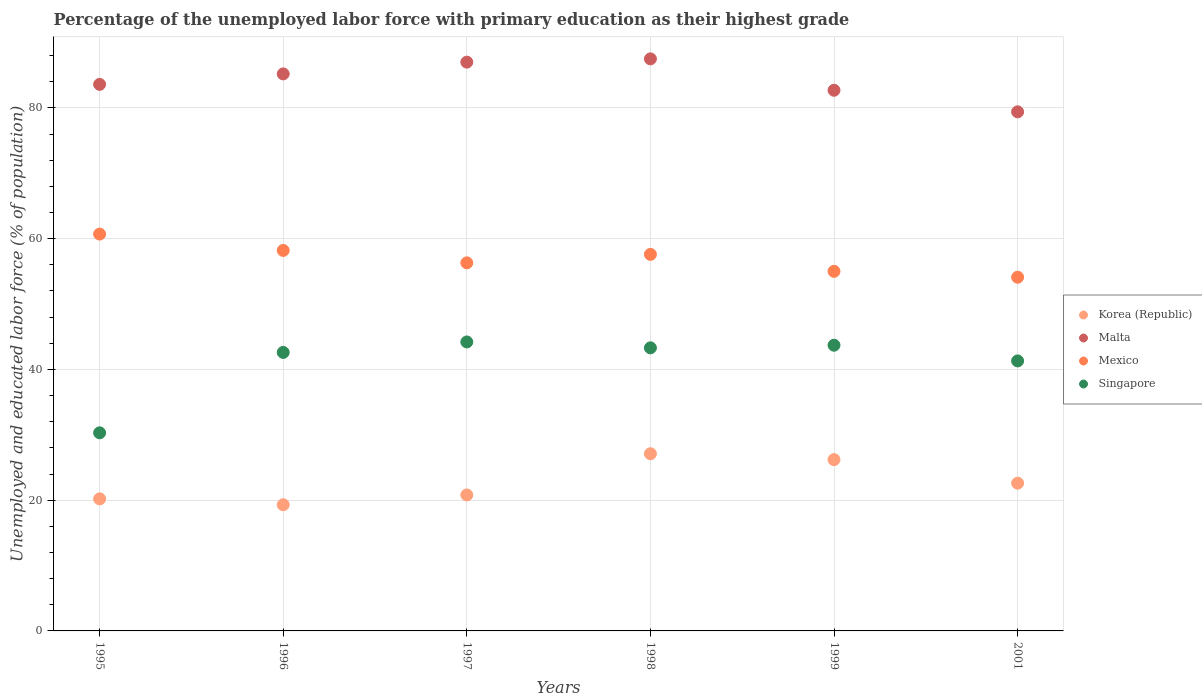How many different coloured dotlines are there?
Make the answer very short. 4. What is the percentage of the unemployed labor force with primary education in Korea (Republic) in 1996?
Keep it short and to the point. 19.3. Across all years, what is the maximum percentage of the unemployed labor force with primary education in Mexico?
Provide a short and direct response. 60.7. Across all years, what is the minimum percentage of the unemployed labor force with primary education in Mexico?
Your response must be concise. 54.1. In which year was the percentage of the unemployed labor force with primary education in Korea (Republic) maximum?
Keep it short and to the point. 1998. What is the total percentage of the unemployed labor force with primary education in Mexico in the graph?
Provide a short and direct response. 341.9. What is the difference between the percentage of the unemployed labor force with primary education in Malta in 1996 and that in 1998?
Provide a short and direct response. -2.3. What is the difference between the percentage of the unemployed labor force with primary education in Singapore in 1998 and the percentage of the unemployed labor force with primary education in Mexico in 1995?
Your answer should be very brief. -17.4. What is the average percentage of the unemployed labor force with primary education in Singapore per year?
Offer a very short reply. 40.9. In the year 1999, what is the difference between the percentage of the unemployed labor force with primary education in Singapore and percentage of the unemployed labor force with primary education in Korea (Republic)?
Give a very brief answer. 17.5. What is the ratio of the percentage of the unemployed labor force with primary education in Korea (Republic) in 1998 to that in 2001?
Keep it short and to the point. 1.2. What is the difference between the highest and the second highest percentage of the unemployed labor force with primary education in Korea (Republic)?
Your answer should be compact. 0.9. What is the difference between the highest and the lowest percentage of the unemployed labor force with primary education in Mexico?
Keep it short and to the point. 6.6. In how many years, is the percentage of the unemployed labor force with primary education in Korea (Republic) greater than the average percentage of the unemployed labor force with primary education in Korea (Republic) taken over all years?
Give a very brief answer. 2. Is it the case that in every year, the sum of the percentage of the unemployed labor force with primary education in Singapore and percentage of the unemployed labor force with primary education in Mexico  is greater than the sum of percentage of the unemployed labor force with primary education in Malta and percentage of the unemployed labor force with primary education in Korea (Republic)?
Provide a succinct answer. Yes. Does the percentage of the unemployed labor force with primary education in Korea (Republic) monotonically increase over the years?
Provide a short and direct response. No. Is the percentage of the unemployed labor force with primary education in Malta strictly greater than the percentage of the unemployed labor force with primary education in Singapore over the years?
Provide a short and direct response. Yes. Is the percentage of the unemployed labor force with primary education in Korea (Republic) strictly less than the percentage of the unemployed labor force with primary education in Singapore over the years?
Provide a succinct answer. Yes. How many dotlines are there?
Provide a succinct answer. 4. How many years are there in the graph?
Make the answer very short. 6. Where does the legend appear in the graph?
Keep it short and to the point. Center right. How are the legend labels stacked?
Give a very brief answer. Vertical. What is the title of the graph?
Offer a terse response. Percentage of the unemployed labor force with primary education as their highest grade. Does "Sub-Saharan Africa (developing only)" appear as one of the legend labels in the graph?
Offer a very short reply. No. What is the label or title of the X-axis?
Give a very brief answer. Years. What is the label or title of the Y-axis?
Ensure brevity in your answer.  Unemployed and educated labor force (% of population). What is the Unemployed and educated labor force (% of population) in Korea (Republic) in 1995?
Your answer should be very brief. 20.2. What is the Unemployed and educated labor force (% of population) in Malta in 1995?
Your answer should be very brief. 83.6. What is the Unemployed and educated labor force (% of population) of Mexico in 1995?
Offer a very short reply. 60.7. What is the Unemployed and educated labor force (% of population) in Singapore in 1995?
Ensure brevity in your answer.  30.3. What is the Unemployed and educated labor force (% of population) of Korea (Republic) in 1996?
Make the answer very short. 19.3. What is the Unemployed and educated labor force (% of population) in Malta in 1996?
Give a very brief answer. 85.2. What is the Unemployed and educated labor force (% of population) of Mexico in 1996?
Your answer should be very brief. 58.2. What is the Unemployed and educated labor force (% of population) in Singapore in 1996?
Your answer should be compact. 42.6. What is the Unemployed and educated labor force (% of population) in Korea (Republic) in 1997?
Offer a very short reply. 20.8. What is the Unemployed and educated labor force (% of population) in Malta in 1997?
Ensure brevity in your answer.  87. What is the Unemployed and educated labor force (% of population) of Mexico in 1997?
Your answer should be compact. 56.3. What is the Unemployed and educated labor force (% of population) of Singapore in 1997?
Keep it short and to the point. 44.2. What is the Unemployed and educated labor force (% of population) of Korea (Republic) in 1998?
Your answer should be compact. 27.1. What is the Unemployed and educated labor force (% of population) of Malta in 1998?
Offer a terse response. 87.5. What is the Unemployed and educated labor force (% of population) in Mexico in 1998?
Ensure brevity in your answer.  57.6. What is the Unemployed and educated labor force (% of population) in Singapore in 1998?
Give a very brief answer. 43.3. What is the Unemployed and educated labor force (% of population) of Korea (Republic) in 1999?
Offer a terse response. 26.2. What is the Unemployed and educated labor force (% of population) of Malta in 1999?
Provide a succinct answer. 82.7. What is the Unemployed and educated labor force (% of population) in Singapore in 1999?
Make the answer very short. 43.7. What is the Unemployed and educated labor force (% of population) in Korea (Republic) in 2001?
Offer a very short reply. 22.6. What is the Unemployed and educated labor force (% of population) of Malta in 2001?
Provide a succinct answer. 79.4. What is the Unemployed and educated labor force (% of population) of Mexico in 2001?
Your answer should be very brief. 54.1. What is the Unemployed and educated labor force (% of population) of Singapore in 2001?
Make the answer very short. 41.3. Across all years, what is the maximum Unemployed and educated labor force (% of population) in Korea (Republic)?
Your answer should be compact. 27.1. Across all years, what is the maximum Unemployed and educated labor force (% of population) of Malta?
Keep it short and to the point. 87.5. Across all years, what is the maximum Unemployed and educated labor force (% of population) in Mexico?
Offer a very short reply. 60.7. Across all years, what is the maximum Unemployed and educated labor force (% of population) in Singapore?
Give a very brief answer. 44.2. Across all years, what is the minimum Unemployed and educated labor force (% of population) in Korea (Republic)?
Offer a terse response. 19.3. Across all years, what is the minimum Unemployed and educated labor force (% of population) of Malta?
Provide a short and direct response. 79.4. Across all years, what is the minimum Unemployed and educated labor force (% of population) of Mexico?
Keep it short and to the point. 54.1. Across all years, what is the minimum Unemployed and educated labor force (% of population) in Singapore?
Offer a very short reply. 30.3. What is the total Unemployed and educated labor force (% of population) in Korea (Republic) in the graph?
Provide a succinct answer. 136.2. What is the total Unemployed and educated labor force (% of population) of Malta in the graph?
Make the answer very short. 505.4. What is the total Unemployed and educated labor force (% of population) in Mexico in the graph?
Make the answer very short. 341.9. What is the total Unemployed and educated labor force (% of population) of Singapore in the graph?
Your answer should be very brief. 245.4. What is the difference between the Unemployed and educated labor force (% of population) in Korea (Republic) in 1995 and that in 1997?
Ensure brevity in your answer.  -0.6. What is the difference between the Unemployed and educated labor force (% of population) of Malta in 1995 and that in 1997?
Ensure brevity in your answer.  -3.4. What is the difference between the Unemployed and educated labor force (% of population) in Singapore in 1995 and that in 1997?
Provide a succinct answer. -13.9. What is the difference between the Unemployed and educated labor force (% of population) of Korea (Republic) in 1995 and that in 1998?
Give a very brief answer. -6.9. What is the difference between the Unemployed and educated labor force (% of population) in Malta in 1995 and that in 1998?
Offer a very short reply. -3.9. What is the difference between the Unemployed and educated labor force (% of population) of Mexico in 1995 and that in 1998?
Keep it short and to the point. 3.1. What is the difference between the Unemployed and educated labor force (% of population) in Korea (Republic) in 1995 and that in 1999?
Ensure brevity in your answer.  -6. What is the difference between the Unemployed and educated labor force (% of population) of Mexico in 1995 and that in 1999?
Your answer should be compact. 5.7. What is the difference between the Unemployed and educated labor force (% of population) of Singapore in 1995 and that in 1999?
Give a very brief answer. -13.4. What is the difference between the Unemployed and educated labor force (% of population) in Korea (Republic) in 1995 and that in 2001?
Keep it short and to the point. -2.4. What is the difference between the Unemployed and educated labor force (% of population) of Malta in 1995 and that in 2001?
Offer a terse response. 4.2. What is the difference between the Unemployed and educated labor force (% of population) in Mexico in 1995 and that in 2001?
Your answer should be compact. 6.6. What is the difference between the Unemployed and educated labor force (% of population) in Singapore in 1995 and that in 2001?
Your answer should be compact. -11. What is the difference between the Unemployed and educated labor force (% of population) in Mexico in 1996 and that in 1997?
Offer a very short reply. 1.9. What is the difference between the Unemployed and educated labor force (% of population) in Singapore in 1996 and that in 1997?
Your answer should be compact. -1.6. What is the difference between the Unemployed and educated labor force (% of population) in Korea (Republic) in 1996 and that in 1998?
Give a very brief answer. -7.8. What is the difference between the Unemployed and educated labor force (% of population) of Mexico in 1996 and that in 1998?
Offer a terse response. 0.6. What is the difference between the Unemployed and educated labor force (% of population) in Korea (Republic) in 1996 and that in 1999?
Provide a short and direct response. -6.9. What is the difference between the Unemployed and educated labor force (% of population) of Malta in 1996 and that in 1999?
Give a very brief answer. 2.5. What is the difference between the Unemployed and educated labor force (% of population) in Mexico in 1996 and that in 1999?
Provide a short and direct response. 3.2. What is the difference between the Unemployed and educated labor force (% of population) of Singapore in 1996 and that in 1999?
Ensure brevity in your answer.  -1.1. What is the difference between the Unemployed and educated labor force (% of population) in Korea (Republic) in 1996 and that in 2001?
Make the answer very short. -3.3. What is the difference between the Unemployed and educated labor force (% of population) in Mexico in 1996 and that in 2001?
Offer a very short reply. 4.1. What is the difference between the Unemployed and educated labor force (% of population) of Korea (Republic) in 1997 and that in 1998?
Provide a short and direct response. -6.3. What is the difference between the Unemployed and educated labor force (% of population) in Malta in 1997 and that in 1998?
Make the answer very short. -0.5. What is the difference between the Unemployed and educated labor force (% of population) of Malta in 1997 and that in 1999?
Your answer should be very brief. 4.3. What is the difference between the Unemployed and educated labor force (% of population) of Singapore in 1997 and that in 1999?
Give a very brief answer. 0.5. What is the difference between the Unemployed and educated labor force (% of population) of Korea (Republic) in 1997 and that in 2001?
Your answer should be compact. -1.8. What is the difference between the Unemployed and educated labor force (% of population) of Malta in 1997 and that in 2001?
Provide a short and direct response. 7.6. What is the difference between the Unemployed and educated labor force (% of population) in Singapore in 1997 and that in 2001?
Offer a terse response. 2.9. What is the difference between the Unemployed and educated labor force (% of population) in Malta in 1998 and that in 1999?
Give a very brief answer. 4.8. What is the difference between the Unemployed and educated labor force (% of population) of Mexico in 1998 and that in 1999?
Your answer should be very brief. 2.6. What is the difference between the Unemployed and educated labor force (% of population) of Korea (Republic) in 1998 and that in 2001?
Ensure brevity in your answer.  4.5. What is the difference between the Unemployed and educated labor force (% of population) in Malta in 1998 and that in 2001?
Your answer should be very brief. 8.1. What is the difference between the Unemployed and educated labor force (% of population) in Singapore in 1998 and that in 2001?
Give a very brief answer. 2. What is the difference between the Unemployed and educated labor force (% of population) in Malta in 1999 and that in 2001?
Ensure brevity in your answer.  3.3. What is the difference between the Unemployed and educated labor force (% of population) of Mexico in 1999 and that in 2001?
Your answer should be very brief. 0.9. What is the difference between the Unemployed and educated labor force (% of population) of Singapore in 1999 and that in 2001?
Provide a succinct answer. 2.4. What is the difference between the Unemployed and educated labor force (% of population) of Korea (Republic) in 1995 and the Unemployed and educated labor force (% of population) of Malta in 1996?
Make the answer very short. -65. What is the difference between the Unemployed and educated labor force (% of population) of Korea (Republic) in 1995 and the Unemployed and educated labor force (% of population) of Mexico in 1996?
Provide a succinct answer. -38. What is the difference between the Unemployed and educated labor force (% of population) in Korea (Republic) in 1995 and the Unemployed and educated labor force (% of population) in Singapore in 1996?
Offer a very short reply. -22.4. What is the difference between the Unemployed and educated labor force (% of population) in Malta in 1995 and the Unemployed and educated labor force (% of population) in Mexico in 1996?
Offer a terse response. 25.4. What is the difference between the Unemployed and educated labor force (% of population) of Malta in 1995 and the Unemployed and educated labor force (% of population) of Singapore in 1996?
Make the answer very short. 41. What is the difference between the Unemployed and educated labor force (% of population) in Mexico in 1995 and the Unemployed and educated labor force (% of population) in Singapore in 1996?
Your response must be concise. 18.1. What is the difference between the Unemployed and educated labor force (% of population) of Korea (Republic) in 1995 and the Unemployed and educated labor force (% of population) of Malta in 1997?
Give a very brief answer. -66.8. What is the difference between the Unemployed and educated labor force (% of population) in Korea (Republic) in 1995 and the Unemployed and educated labor force (% of population) in Mexico in 1997?
Ensure brevity in your answer.  -36.1. What is the difference between the Unemployed and educated labor force (% of population) in Malta in 1995 and the Unemployed and educated labor force (% of population) in Mexico in 1997?
Offer a very short reply. 27.3. What is the difference between the Unemployed and educated labor force (% of population) of Malta in 1995 and the Unemployed and educated labor force (% of population) of Singapore in 1997?
Ensure brevity in your answer.  39.4. What is the difference between the Unemployed and educated labor force (% of population) in Korea (Republic) in 1995 and the Unemployed and educated labor force (% of population) in Malta in 1998?
Make the answer very short. -67.3. What is the difference between the Unemployed and educated labor force (% of population) of Korea (Republic) in 1995 and the Unemployed and educated labor force (% of population) of Mexico in 1998?
Provide a succinct answer. -37.4. What is the difference between the Unemployed and educated labor force (% of population) of Korea (Republic) in 1995 and the Unemployed and educated labor force (% of population) of Singapore in 1998?
Offer a terse response. -23.1. What is the difference between the Unemployed and educated labor force (% of population) of Malta in 1995 and the Unemployed and educated labor force (% of population) of Singapore in 1998?
Your answer should be very brief. 40.3. What is the difference between the Unemployed and educated labor force (% of population) in Mexico in 1995 and the Unemployed and educated labor force (% of population) in Singapore in 1998?
Your response must be concise. 17.4. What is the difference between the Unemployed and educated labor force (% of population) of Korea (Republic) in 1995 and the Unemployed and educated labor force (% of population) of Malta in 1999?
Provide a succinct answer. -62.5. What is the difference between the Unemployed and educated labor force (% of population) of Korea (Republic) in 1995 and the Unemployed and educated labor force (% of population) of Mexico in 1999?
Offer a terse response. -34.8. What is the difference between the Unemployed and educated labor force (% of population) in Korea (Republic) in 1995 and the Unemployed and educated labor force (% of population) in Singapore in 1999?
Your response must be concise. -23.5. What is the difference between the Unemployed and educated labor force (% of population) of Malta in 1995 and the Unemployed and educated labor force (% of population) of Mexico in 1999?
Make the answer very short. 28.6. What is the difference between the Unemployed and educated labor force (% of population) of Malta in 1995 and the Unemployed and educated labor force (% of population) of Singapore in 1999?
Your answer should be very brief. 39.9. What is the difference between the Unemployed and educated labor force (% of population) of Mexico in 1995 and the Unemployed and educated labor force (% of population) of Singapore in 1999?
Provide a short and direct response. 17. What is the difference between the Unemployed and educated labor force (% of population) in Korea (Republic) in 1995 and the Unemployed and educated labor force (% of population) in Malta in 2001?
Your answer should be very brief. -59.2. What is the difference between the Unemployed and educated labor force (% of population) of Korea (Republic) in 1995 and the Unemployed and educated labor force (% of population) of Mexico in 2001?
Provide a succinct answer. -33.9. What is the difference between the Unemployed and educated labor force (% of population) in Korea (Republic) in 1995 and the Unemployed and educated labor force (% of population) in Singapore in 2001?
Keep it short and to the point. -21.1. What is the difference between the Unemployed and educated labor force (% of population) of Malta in 1995 and the Unemployed and educated labor force (% of population) of Mexico in 2001?
Provide a succinct answer. 29.5. What is the difference between the Unemployed and educated labor force (% of population) of Malta in 1995 and the Unemployed and educated labor force (% of population) of Singapore in 2001?
Offer a terse response. 42.3. What is the difference between the Unemployed and educated labor force (% of population) in Mexico in 1995 and the Unemployed and educated labor force (% of population) in Singapore in 2001?
Give a very brief answer. 19.4. What is the difference between the Unemployed and educated labor force (% of population) in Korea (Republic) in 1996 and the Unemployed and educated labor force (% of population) in Malta in 1997?
Ensure brevity in your answer.  -67.7. What is the difference between the Unemployed and educated labor force (% of population) of Korea (Republic) in 1996 and the Unemployed and educated labor force (% of population) of Mexico in 1997?
Make the answer very short. -37. What is the difference between the Unemployed and educated labor force (% of population) in Korea (Republic) in 1996 and the Unemployed and educated labor force (% of population) in Singapore in 1997?
Your answer should be very brief. -24.9. What is the difference between the Unemployed and educated labor force (% of population) of Malta in 1996 and the Unemployed and educated labor force (% of population) of Mexico in 1997?
Ensure brevity in your answer.  28.9. What is the difference between the Unemployed and educated labor force (% of population) in Malta in 1996 and the Unemployed and educated labor force (% of population) in Singapore in 1997?
Provide a short and direct response. 41. What is the difference between the Unemployed and educated labor force (% of population) in Mexico in 1996 and the Unemployed and educated labor force (% of population) in Singapore in 1997?
Provide a short and direct response. 14. What is the difference between the Unemployed and educated labor force (% of population) of Korea (Republic) in 1996 and the Unemployed and educated labor force (% of population) of Malta in 1998?
Provide a short and direct response. -68.2. What is the difference between the Unemployed and educated labor force (% of population) of Korea (Republic) in 1996 and the Unemployed and educated labor force (% of population) of Mexico in 1998?
Keep it short and to the point. -38.3. What is the difference between the Unemployed and educated labor force (% of population) in Korea (Republic) in 1996 and the Unemployed and educated labor force (% of population) in Singapore in 1998?
Your response must be concise. -24. What is the difference between the Unemployed and educated labor force (% of population) in Malta in 1996 and the Unemployed and educated labor force (% of population) in Mexico in 1998?
Offer a terse response. 27.6. What is the difference between the Unemployed and educated labor force (% of population) of Malta in 1996 and the Unemployed and educated labor force (% of population) of Singapore in 1998?
Your response must be concise. 41.9. What is the difference between the Unemployed and educated labor force (% of population) in Mexico in 1996 and the Unemployed and educated labor force (% of population) in Singapore in 1998?
Your answer should be compact. 14.9. What is the difference between the Unemployed and educated labor force (% of population) in Korea (Republic) in 1996 and the Unemployed and educated labor force (% of population) in Malta in 1999?
Keep it short and to the point. -63.4. What is the difference between the Unemployed and educated labor force (% of population) in Korea (Republic) in 1996 and the Unemployed and educated labor force (% of population) in Mexico in 1999?
Your answer should be very brief. -35.7. What is the difference between the Unemployed and educated labor force (% of population) of Korea (Republic) in 1996 and the Unemployed and educated labor force (% of population) of Singapore in 1999?
Keep it short and to the point. -24.4. What is the difference between the Unemployed and educated labor force (% of population) in Malta in 1996 and the Unemployed and educated labor force (% of population) in Mexico in 1999?
Make the answer very short. 30.2. What is the difference between the Unemployed and educated labor force (% of population) in Malta in 1996 and the Unemployed and educated labor force (% of population) in Singapore in 1999?
Give a very brief answer. 41.5. What is the difference between the Unemployed and educated labor force (% of population) of Mexico in 1996 and the Unemployed and educated labor force (% of population) of Singapore in 1999?
Your response must be concise. 14.5. What is the difference between the Unemployed and educated labor force (% of population) in Korea (Republic) in 1996 and the Unemployed and educated labor force (% of population) in Malta in 2001?
Ensure brevity in your answer.  -60.1. What is the difference between the Unemployed and educated labor force (% of population) of Korea (Republic) in 1996 and the Unemployed and educated labor force (% of population) of Mexico in 2001?
Offer a very short reply. -34.8. What is the difference between the Unemployed and educated labor force (% of population) of Korea (Republic) in 1996 and the Unemployed and educated labor force (% of population) of Singapore in 2001?
Your answer should be very brief. -22. What is the difference between the Unemployed and educated labor force (% of population) of Malta in 1996 and the Unemployed and educated labor force (% of population) of Mexico in 2001?
Offer a terse response. 31.1. What is the difference between the Unemployed and educated labor force (% of population) in Malta in 1996 and the Unemployed and educated labor force (% of population) in Singapore in 2001?
Ensure brevity in your answer.  43.9. What is the difference between the Unemployed and educated labor force (% of population) in Korea (Republic) in 1997 and the Unemployed and educated labor force (% of population) in Malta in 1998?
Your answer should be very brief. -66.7. What is the difference between the Unemployed and educated labor force (% of population) in Korea (Republic) in 1997 and the Unemployed and educated labor force (% of population) in Mexico in 1998?
Provide a short and direct response. -36.8. What is the difference between the Unemployed and educated labor force (% of population) of Korea (Republic) in 1997 and the Unemployed and educated labor force (% of population) of Singapore in 1998?
Offer a terse response. -22.5. What is the difference between the Unemployed and educated labor force (% of population) of Malta in 1997 and the Unemployed and educated labor force (% of population) of Mexico in 1998?
Give a very brief answer. 29.4. What is the difference between the Unemployed and educated labor force (% of population) in Malta in 1997 and the Unemployed and educated labor force (% of population) in Singapore in 1998?
Give a very brief answer. 43.7. What is the difference between the Unemployed and educated labor force (% of population) in Korea (Republic) in 1997 and the Unemployed and educated labor force (% of population) in Malta in 1999?
Your answer should be very brief. -61.9. What is the difference between the Unemployed and educated labor force (% of population) of Korea (Republic) in 1997 and the Unemployed and educated labor force (% of population) of Mexico in 1999?
Ensure brevity in your answer.  -34.2. What is the difference between the Unemployed and educated labor force (% of population) of Korea (Republic) in 1997 and the Unemployed and educated labor force (% of population) of Singapore in 1999?
Provide a succinct answer. -22.9. What is the difference between the Unemployed and educated labor force (% of population) of Malta in 1997 and the Unemployed and educated labor force (% of population) of Mexico in 1999?
Provide a succinct answer. 32. What is the difference between the Unemployed and educated labor force (% of population) of Malta in 1997 and the Unemployed and educated labor force (% of population) of Singapore in 1999?
Offer a very short reply. 43.3. What is the difference between the Unemployed and educated labor force (% of population) in Korea (Republic) in 1997 and the Unemployed and educated labor force (% of population) in Malta in 2001?
Your response must be concise. -58.6. What is the difference between the Unemployed and educated labor force (% of population) of Korea (Republic) in 1997 and the Unemployed and educated labor force (% of population) of Mexico in 2001?
Give a very brief answer. -33.3. What is the difference between the Unemployed and educated labor force (% of population) in Korea (Republic) in 1997 and the Unemployed and educated labor force (% of population) in Singapore in 2001?
Offer a terse response. -20.5. What is the difference between the Unemployed and educated labor force (% of population) in Malta in 1997 and the Unemployed and educated labor force (% of population) in Mexico in 2001?
Your answer should be compact. 32.9. What is the difference between the Unemployed and educated labor force (% of population) of Malta in 1997 and the Unemployed and educated labor force (% of population) of Singapore in 2001?
Provide a succinct answer. 45.7. What is the difference between the Unemployed and educated labor force (% of population) in Korea (Republic) in 1998 and the Unemployed and educated labor force (% of population) in Malta in 1999?
Provide a succinct answer. -55.6. What is the difference between the Unemployed and educated labor force (% of population) in Korea (Republic) in 1998 and the Unemployed and educated labor force (% of population) in Mexico in 1999?
Provide a succinct answer. -27.9. What is the difference between the Unemployed and educated labor force (% of population) in Korea (Republic) in 1998 and the Unemployed and educated labor force (% of population) in Singapore in 1999?
Offer a terse response. -16.6. What is the difference between the Unemployed and educated labor force (% of population) of Malta in 1998 and the Unemployed and educated labor force (% of population) of Mexico in 1999?
Provide a succinct answer. 32.5. What is the difference between the Unemployed and educated labor force (% of population) of Malta in 1998 and the Unemployed and educated labor force (% of population) of Singapore in 1999?
Your response must be concise. 43.8. What is the difference between the Unemployed and educated labor force (% of population) of Mexico in 1998 and the Unemployed and educated labor force (% of population) of Singapore in 1999?
Make the answer very short. 13.9. What is the difference between the Unemployed and educated labor force (% of population) of Korea (Republic) in 1998 and the Unemployed and educated labor force (% of population) of Malta in 2001?
Your answer should be very brief. -52.3. What is the difference between the Unemployed and educated labor force (% of population) of Korea (Republic) in 1998 and the Unemployed and educated labor force (% of population) of Mexico in 2001?
Provide a succinct answer. -27. What is the difference between the Unemployed and educated labor force (% of population) in Korea (Republic) in 1998 and the Unemployed and educated labor force (% of population) in Singapore in 2001?
Your response must be concise. -14.2. What is the difference between the Unemployed and educated labor force (% of population) of Malta in 1998 and the Unemployed and educated labor force (% of population) of Mexico in 2001?
Offer a very short reply. 33.4. What is the difference between the Unemployed and educated labor force (% of population) of Malta in 1998 and the Unemployed and educated labor force (% of population) of Singapore in 2001?
Provide a short and direct response. 46.2. What is the difference between the Unemployed and educated labor force (% of population) in Korea (Republic) in 1999 and the Unemployed and educated labor force (% of population) in Malta in 2001?
Offer a terse response. -53.2. What is the difference between the Unemployed and educated labor force (% of population) of Korea (Republic) in 1999 and the Unemployed and educated labor force (% of population) of Mexico in 2001?
Provide a succinct answer. -27.9. What is the difference between the Unemployed and educated labor force (% of population) in Korea (Republic) in 1999 and the Unemployed and educated labor force (% of population) in Singapore in 2001?
Give a very brief answer. -15.1. What is the difference between the Unemployed and educated labor force (% of population) of Malta in 1999 and the Unemployed and educated labor force (% of population) of Mexico in 2001?
Offer a terse response. 28.6. What is the difference between the Unemployed and educated labor force (% of population) of Malta in 1999 and the Unemployed and educated labor force (% of population) of Singapore in 2001?
Make the answer very short. 41.4. What is the average Unemployed and educated labor force (% of population) in Korea (Republic) per year?
Ensure brevity in your answer.  22.7. What is the average Unemployed and educated labor force (% of population) in Malta per year?
Provide a short and direct response. 84.23. What is the average Unemployed and educated labor force (% of population) in Mexico per year?
Keep it short and to the point. 56.98. What is the average Unemployed and educated labor force (% of population) of Singapore per year?
Your answer should be compact. 40.9. In the year 1995, what is the difference between the Unemployed and educated labor force (% of population) of Korea (Republic) and Unemployed and educated labor force (% of population) of Malta?
Make the answer very short. -63.4. In the year 1995, what is the difference between the Unemployed and educated labor force (% of population) of Korea (Republic) and Unemployed and educated labor force (% of population) of Mexico?
Provide a short and direct response. -40.5. In the year 1995, what is the difference between the Unemployed and educated labor force (% of population) in Korea (Republic) and Unemployed and educated labor force (% of population) in Singapore?
Make the answer very short. -10.1. In the year 1995, what is the difference between the Unemployed and educated labor force (% of population) of Malta and Unemployed and educated labor force (% of population) of Mexico?
Offer a terse response. 22.9. In the year 1995, what is the difference between the Unemployed and educated labor force (% of population) in Malta and Unemployed and educated labor force (% of population) in Singapore?
Make the answer very short. 53.3. In the year 1995, what is the difference between the Unemployed and educated labor force (% of population) of Mexico and Unemployed and educated labor force (% of population) of Singapore?
Your answer should be compact. 30.4. In the year 1996, what is the difference between the Unemployed and educated labor force (% of population) of Korea (Republic) and Unemployed and educated labor force (% of population) of Malta?
Keep it short and to the point. -65.9. In the year 1996, what is the difference between the Unemployed and educated labor force (% of population) in Korea (Republic) and Unemployed and educated labor force (% of population) in Mexico?
Give a very brief answer. -38.9. In the year 1996, what is the difference between the Unemployed and educated labor force (% of population) of Korea (Republic) and Unemployed and educated labor force (% of population) of Singapore?
Your answer should be compact. -23.3. In the year 1996, what is the difference between the Unemployed and educated labor force (% of population) of Malta and Unemployed and educated labor force (% of population) of Singapore?
Your answer should be very brief. 42.6. In the year 1996, what is the difference between the Unemployed and educated labor force (% of population) of Mexico and Unemployed and educated labor force (% of population) of Singapore?
Ensure brevity in your answer.  15.6. In the year 1997, what is the difference between the Unemployed and educated labor force (% of population) of Korea (Republic) and Unemployed and educated labor force (% of population) of Malta?
Your answer should be compact. -66.2. In the year 1997, what is the difference between the Unemployed and educated labor force (% of population) in Korea (Republic) and Unemployed and educated labor force (% of population) in Mexico?
Your answer should be very brief. -35.5. In the year 1997, what is the difference between the Unemployed and educated labor force (% of population) of Korea (Republic) and Unemployed and educated labor force (% of population) of Singapore?
Your answer should be compact. -23.4. In the year 1997, what is the difference between the Unemployed and educated labor force (% of population) of Malta and Unemployed and educated labor force (% of population) of Mexico?
Provide a succinct answer. 30.7. In the year 1997, what is the difference between the Unemployed and educated labor force (% of population) in Malta and Unemployed and educated labor force (% of population) in Singapore?
Provide a succinct answer. 42.8. In the year 1997, what is the difference between the Unemployed and educated labor force (% of population) of Mexico and Unemployed and educated labor force (% of population) of Singapore?
Keep it short and to the point. 12.1. In the year 1998, what is the difference between the Unemployed and educated labor force (% of population) of Korea (Republic) and Unemployed and educated labor force (% of population) of Malta?
Your answer should be very brief. -60.4. In the year 1998, what is the difference between the Unemployed and educated labor force (% of population) of Korea (Republic) and Unemployed and educated labor force (% of population) of Mexico?
Your response must be concise. -30.5. In the year 1998, what is the difference between the Unemployed and educated labor force (% of population) of Korea (Republic) and Unemployed and educated labor force (% of population) of Singapore?
Give a very brief answer. -16.2. In the year 1998, what is the difference between the Unemployed and educated labor force (% of population) of Malta and Unemployed and educated labor force (% of population) of Mexico?
Offer a terse response. 29.9. In the year 1998, what is the difference between the Unemployed and educated labor force (% of population) of Malta and Unemployed and educated labor force (% of population) of Singapore?
Your answer should be very brief. 44.2. In the year 1998, what is the difference between the Unemployed and educated labor force (% of population) of Mexico and Unemployed and educated labor force (% of population) of Singapore?
Your answer should be very brief. 14.3. In the year 1999, what is the difference between the Unemployed and educated labor force (% of population) of Korea (Republic) and Unemployed and educated labor force (% of population) of Malta?
Offer a very short reply. -56.5. In the year 1999, what is the difference between the Unemployed and educated labor force (% of population) in Korea (Republic) and Unemployed and educated labor force (% of population) in Mexico?
Your answer should be very brief. -28.8. In the year 1999, what is the difference between the Unemployed and educated labor force (% of population) in Korea (Republic) and Unemployed and educated labor force (% of population) in Singapore?
Keep it short and to the point. -17.5. In the year 1999, what is the difference between the Unemployed and educated labor force (% of population) in Malta and Unemployed and educated labor force (% of population) in Mexico?
Your answer should be very brief. 27.7. In the year 1999, what is the difference between the Unemployed and educated labor force (% of population) in Malta and Unemployed and educated labor force (% of population) in Singapore?
Provide a succinct answer. 39. In the year 2001, what is the difference between the Unemployed and educated labor force (% of population) in Korea (Republic) and Unemployed and educated labor force (% of population) in Malta?
Provide a short and direct response. -56.8. In the year 2001, what is the difference between the Unemployed and educated labor force (% of population) in Korea (Republic) and Unemployed and educated labor force (% of population) in Mexico?
Offer a terse response. -31.5. In the year 2001, what is the difference between the Unemployed and educated labor force (% of population) of Korea (Republic) and Unemployed and educated labor force (% of population) of Singapore?
Make the answer very short. -18.7. In the year 2001, what is the difference between the Unemployed and educated labor force (% of population) of Malta and Unemployed and educated labor force (% of population) of Mexico?
Give a very brief answer. 25.3. In the year 2001, what is the difference between the Unemployed and educated labor force (% of population) in Malta and Unemployed and educated labor force (% of population) in Singapore?
Provide a succinct answer. 38.1. In the year 2001, what is the difference between the Unemployed and educated labor force (% of population) of Mexico and Unemployed and educated labor force (% of population) of Singapore?
Provide a succinct answer. 12.8. What is the ratio of the Unemployed and educated labor force (% of population) in Korea (Republic) in 1995 to that in 1996?
Your answer should be very brief. 1.05. What is the ratio of the Unemployed and educated labor force (% of population) of Malta in 1995 to that in 1996?
Provide a succinct answer. 0.98. What is the ratio of the Unemployed and educated labor force (% of population) of Mexico in 1995 to that in 1996?
Ensure brevity in your answer.  1.04. What is the ratio of the Unemployed and educated labor force (% of population) in Singapore in 1995 to that in 1996?
Offer a very short reply. 0.71. What is the ratio of the Unemployed and educated labor force (% of population) of Korea (Republic) in 1995 to that in 1997?
Your answer should be very brief. 0.97. What is the ratio of the Unemployed and educated labor force (% of population) in Malta in 1995 to that in 1997?
Your answer should be compact. 0.96. What is the ratio of the Unemployed and educated labor force (% of population) of Mexico in 1995 to that in 1997?
Give a very brief answer. 1.08. What is the ratio of the Unemployed and educated labor force (% of population) in Singapore in 1995 to that in 1997?
Provide a succinct answer. 0.69. What is the ratio of the Unemployed and educated labor force (% of population) of Korea (Republic) in 1995 to that in 1998?
Keep it short and to the point. 0.75. What is the ratio of the Unemployed and educated labor force (% of population) in Malta in 1995 to that in 1998?
Your response must be concise. 0.96. What is the ratio of the Unemployed and educated labor force (% of population) of Mexico in 1995 to that in 1998?
Keep it short and to the point. 1.05. What is the ratio of the Unemployed and educated labor force (% of population) of Singapore in 1995 to that in 1998?
Make the answer very short. 0.7. What is the ratio of the Unemployed and educated labor force (% of population) in Korea (Republic) in 1995 to that in 1999?
Offer a very short reply. 0.77. What is the ratio of the Unemployed and educated labor force (% of population) in Malta in 1995 to that in 1999?
Your answer should be compact. 1.01. What is the ratio of the Unemployed and educated labor force (% of population) in Mexico in 1995 to that in 1999?
Provide a succinct answer. 1.1. What is the ratio of the Unemployed and educated labor force (% of population) in Singapore in 1995 to that in 1999?
Keep it short and to the point. 0.69. What is the ratio of the Unemployed and educated labor force (% of population) of Korea (Republic) in 1995 to that in 2001?
Provide a short and direct response. 0.89. What is the ratio of the Unemployed and educated labor force (% of population) in Malta in 1995 to that in 2001?
Make the answer very short. 1.05. What is the ratio of the Unemployed and educated labor force (% of population) of Mexico in 1995 to that in 2001?
Your answer should be very brief. 1.12. What is the ratio of the Unemployed and educated labor force (% of population) in Singapore in 1995 to that in 2001?
Offer a very short reply. 0.73. What is the ratio of the Unemployed and educated labor force (% of population) in Korea (Republic) in 1996 to that in 1997?
Your answer should be very brief. 0.93. What is the ratio of the Unemployed and educated labor force (% of population) in Malta in 1996 to that in 1997?
Your response must be concise. 0.98. What is the ratio of the Unemployed and educated labor force (% of population) of Mexico in 1996 to that in 1997?
Provide a succinct answer. 1.03. What is the ratio of the Unemployed and educated labor force (% of population) of Singapore in 1996 to that in 1997?
Provide a short and direct response. 0.96. What is the ratio of the Unemployed and educated labor force (% of population) in Korea (Republic) in 1996 to that in 1998?
Provide a short and direct response. 0.71. What is the ratio of the Unemployed and educated labor force (% of population) in Malta in 1996 to that in 1998?
Give a very brief answer. 0.97. What is the ratio of the Unemployed and educated labor force (% of population) of Mexico in 1996 to that in 1998?
Keep it short and to the point. 1.01. What is the ratio of the Unemployed and educated labor force (% of population) of Singapore in 1996 to that in 1998?
Provide a succinct answer. 0.98. What is the ratio of the Unemployed and educated labor force (% of population) of Korea (Republic) in 1996 to that in 1999?
Provide a succinct answer. 0.74. What is the ratio of the Unemployed and educated labor force (% of population) of Malta in 1996 to that in 1999?
Keep it short and to the point. 1.03. What is the ratio of the Unemployed and educated labor force (% of population) in Mexico in 1996 to that in 1999?
Make the answer very short. 1.06. What is the ratio of the Unemployed and educated labor force (% of population) in Singapore in 1996 to that in 1999?
Your answer should be compact. 0.97. What is the ratio of the Unemployed and educated labor force (% of population) in Korea (Republic) in 1996 to that in 2001?
Your response must be concise. 0.85. What is the ratio of the Unemployed and educated labor force (% of population) in Malta in 1996 to that in 2001?
Provide a short and direct response. 1.07. What is the ratio of the Unemployed and educated labor force (% of population) of Mexico in 1996 to that in 2001?
Offer a terse response. 1.08. What is the ratio of the Unemployed and educated labor force (% of population) of Singapore in 1996 to that in 2001?
Ensure brevity in your answer.  1.03. What is the ratio of the Unemployed and educated labor force (% of population) in Korea (Republic) in 1997 to that in 1998?
Provide a short and direct response. 0.77. What is the ratio of the Unemployed and educated labor force (% of population) in Malta in 1997 to that in 1998?
Offer a terse response. 0.99. What is the ratio of the Unemployed and educated labor force (% of population) of Mexico in 1997 to that in 1998?
Offer a very short reply. 0.98. What is the ratio of the Unemployed and educated labor force (% of population) of Singapore in 1997 to that in 1998?
Offer a terse response. 1.02. What is the ratio of the Unemployed and educated labor force (% of population) in Korea (Republic) in 1997 to that in 1999?
Make the answer very short. 0.79. What is the ratio of the Unemployed and educated labor force (% of population) in Malta in 1997 to that in 1999?
Your answer should be very brief. 1.05. What is the ratio of the Unemployed and educated labor force (% of population) of Mexico in 1997 to that in 1999?
Offer a terse response. 1.02. What is the ratio of the Unemployed and educated labor force (% of population) in Singapore in 1997 to that in 1999?
Keep it short and to the point. 1.01. What is the ratio of the Unemployed and educated labor force (% of population) in Korea (Republic) in 1997 to that in 2001?
Your answer should be compact. 0.92. What is the ratio of the Unemployed and educated labor force (% of population) of Malta in 1997 to that in 2001?
Your response must be concise. 1.1. What is the ratio of the Unemployed and educated labor force (% of population) of Mexico in 1997 to that in 2001?
Provide a short and direct response. 1.04. What is the ratio of the Unemployed and educated labor force (% of population) of Singapore in 1997 to that in 2001?
Ensure brevity in your answer.  1.07. What is the ratio of the Unemployed and educated labor force (% of population) of Korea (Republic) in 1998 to that in 1999?
Provide a short and direct response. 1.03. What is the ratio of the Unemployed and educated labor force (% of population) of Malta in 1998 to that in 1999?
Your answer should be compact. 1.06. What is the ratio of the Unemployed and educated labor force (% of population) in Mexico in 1998 to that in 1999?
Make the answer very short. 1.05. What is the ratio of the Unemployed and educated labor force (% of population) in Singapore in 1998 to that in 1999?
Offer a terse response. 0.99. What is the ratio of the Unemployed and educated labor force (% of population) in Korea (Republic) in 1998 to that in 2001?
Your answer should be compact. 1.2. What is the ratio of the Unemployed and educated labor force (% of population) in Malta in 1998 to that in 2001?
Give a very brief answer. 1.1. What is the ratio of the Unemployed and educated labor force (% of population) in Mexico in 1998 to that in 2001?
Your answer should be very brief. 1.06. What is the ratio of the Unemployed and educated labor force (% of population) of Singapore in 1998 to that in 2001?
Give a very brief answer. 1.05. What is the ratio of the Unemployed and educated labor force (% of population) in Korea (Republic) in 1999 to that in 2001?
Your answer should be very brief. 1.16. What is the ratio of the Unemployed and educated labor force (% of population) in Malta in 1999 to that in 2001?
Your answer should be compact. 1.04. What is the ratio of the Unemployed and educated labor force (% of population) in Mexico in 1999 to that in 2001?
Your response must be concise. 1.02. What is the ratio of the Unemployed and educated labor force (% of population) in Singapore in 1999 to that in 2001?
Give a very brief answer. 1.06. What is the difference between the highest and the second highest Unemployed and educated labor force (% of population) of Korea (Republic)?
Provide a short and direct response. 0.9. What is the difference between the highest and the second highest Unemployed and educated labor force (% of population) in Mexico?
Ensure brevity in your answer.  2.5. What is the difference between the highest and the lowest Unemployed and educated labor force (% of population) in Korea (Republic)?
Provide a short and direct response. 7.8. What is the difference between the highest and the lowest Unemployed and educated labor force (% of population) of Mexico?
Ensure brevity in your answer.  6.6. 